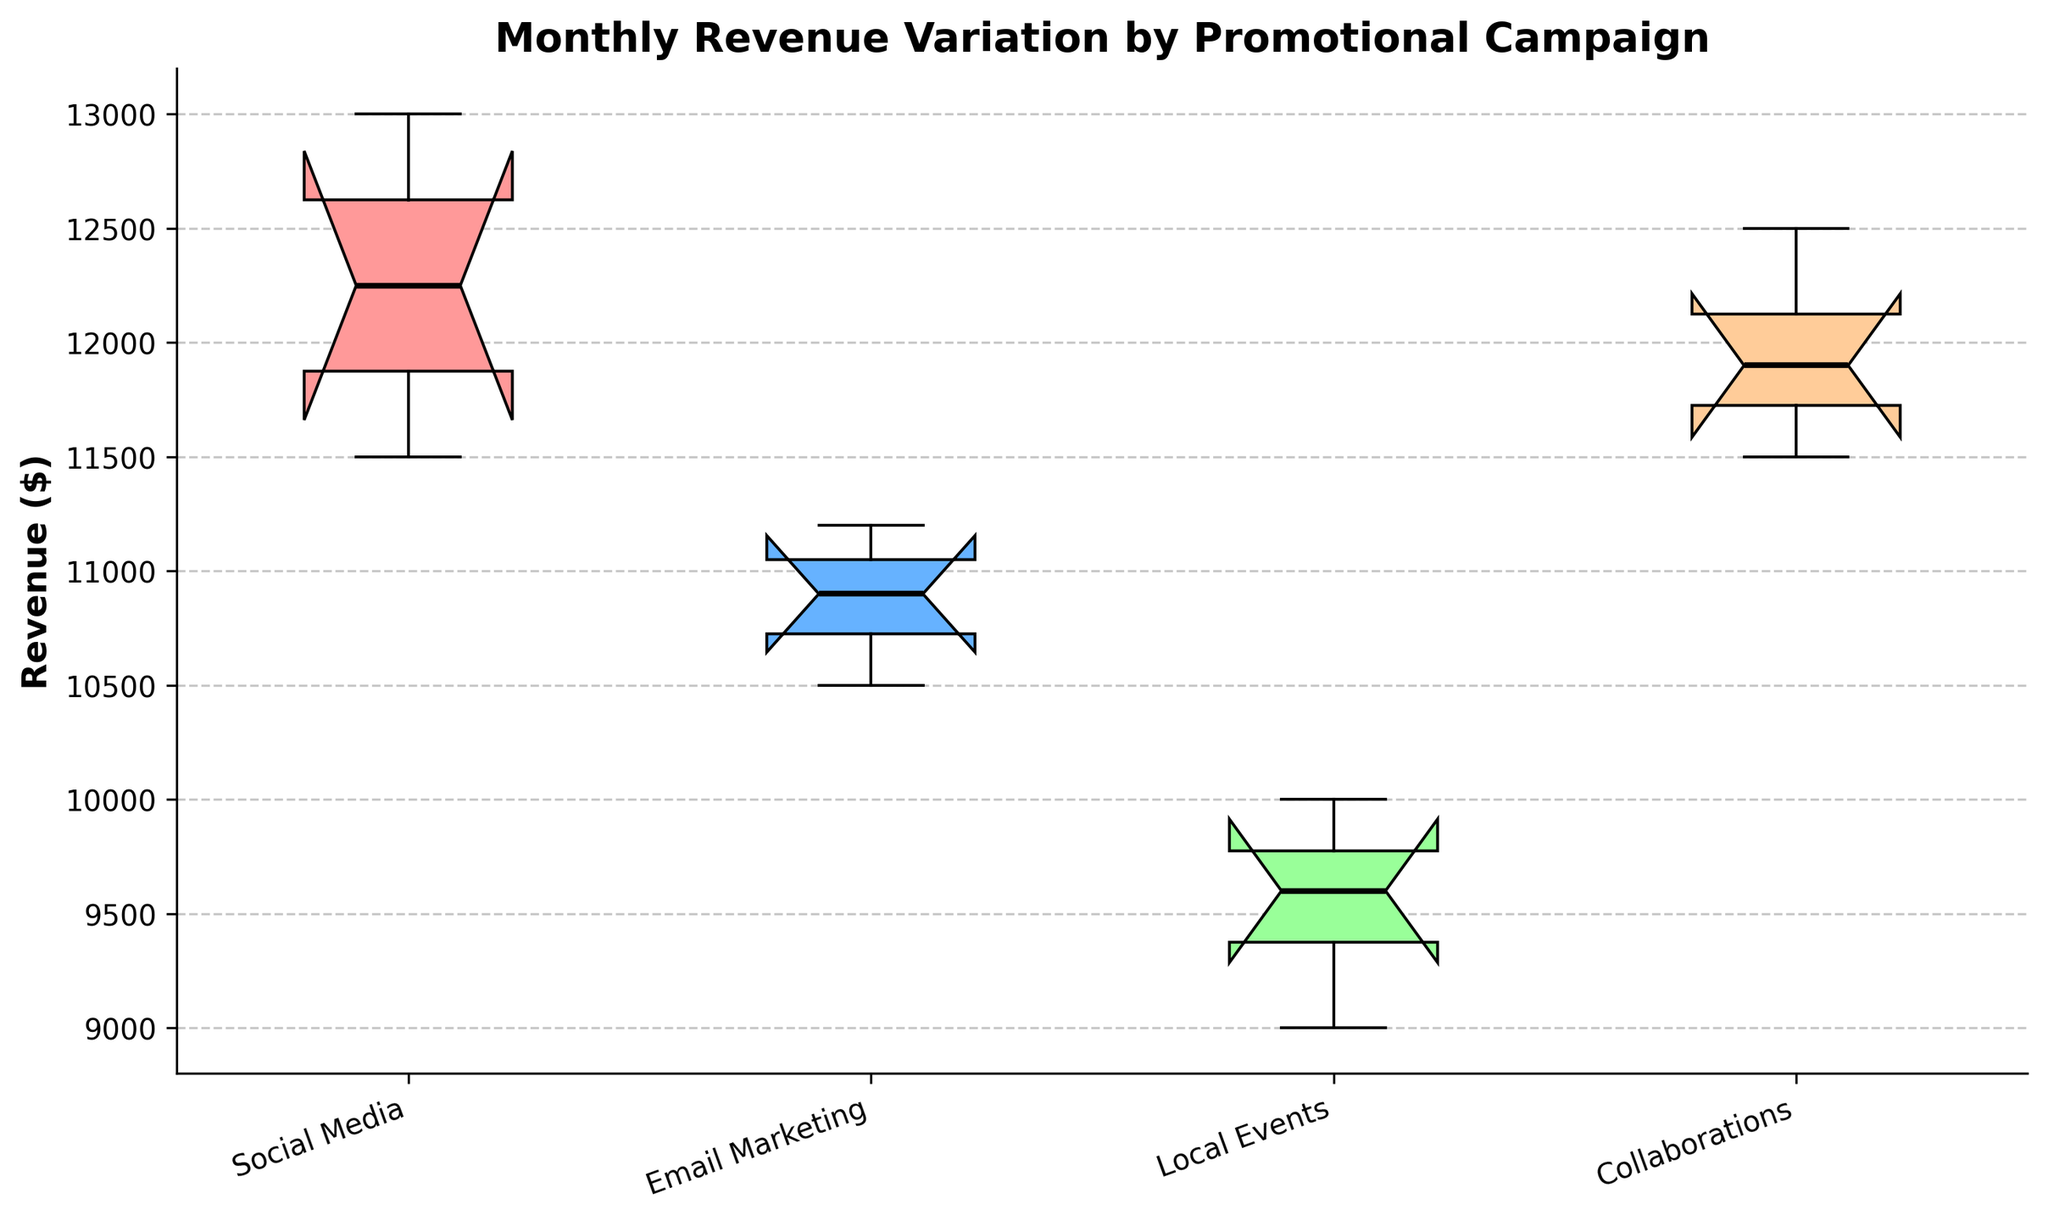What is the title of the plot? The title of the plot is located at the top and prominently displayed in bold font. It reads: "Monthly Revenue Variation by Promotional Campaign".
Answer: Monthly Revenue Variation by Promotional Campaign What are the colors used for the notched boxes? Each notched box is shaded with a distinctive color. The colors are: light red, light blue, light green, and light orange.
Answer: Light red, light blue, light green, light orange Which campaign has the highest median revenue? Look at the middle line inside each notched box plot, which represents the median. Among the four campaigns, the notched box for "Social Media" has the highest median line.
Answer: Social Media What is the range of revenues for the "Email Marketing" campaign? The range is the difference between the maximum and minimum values within the whiskers of the box plot for "Email Marketing". It ranges from around $10,500 to $11,200.
Answer: $10,500 to $11,200 How does the interquartile range (IQR) for the "Local Events" campaign compare to the "Collaborations" campaign? The IQR is indicated by the height of the box. "Local Events" has a larger IQR compared to "Collaborations", as its box is taller. This suggests more variability in the middle 50% of the revenue data.
Answer: Larger in Local Events Which campaign displays the least amount of revenue variation? The variation can be inferred from the height of the box and the overall length of the whiskers. "Email Marketing" shows the least variation as its box and whiskers are the shortest.
Answer: Email Marketing Between "Local Events" and "Collaborations," which has a higher upper whisker value? The upper whisker of a notched box plot represents the maximum value, excluding outliers. "Collaborations" has a higher upper whisker value than "Local Events".
Answer: Collaborations Are there any potential outliers in the "Social Media" campaign's revenue data? Check if there are any data points beyond the whiskers, marked typically by distinct shapes. For "Social Media," no separate points are visible beyond the whiskers, indicating no apparent outliers.
Answer: No What does the notch in the box plot represent, particularly for "Social Media"? The notch gives an approximate confidence interval for the median. If notches from two boxes do not overlap, it suggests a significant difference in medians. For "Social Media," the notch suggests that the median might be statistically different compared to others if overlaps are minimal.
Answer: Confidence interval for the median Based on the figure, which campaign appears to be the most effective in promoting higher revenues? "Social Media" not only shows the highest median revenue, but also has a compact distribution indicating consistent performance. This makes it the most effective in promoting higher revenues.
Answer: Social Media 